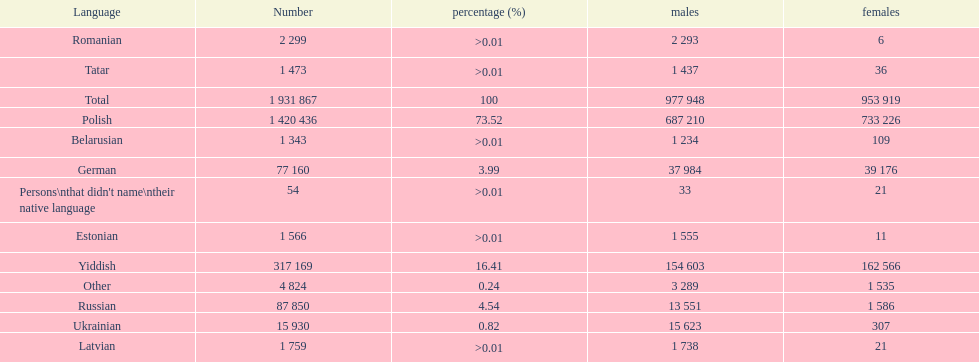Which language had the smallest number of females speaking it. Romanian. Could you parse the entire table as a dict? {'header': ['Language', 'Number', 'percentage (%)', 'males', 'females'], 'rows': [['Romanian', '2 299', '>0.01', '2 293', '6'], ['Tatar', '1 473', '>0.01', '1 437', '36'], ['Total', '1 931 867', '100', '977 948', '953 919'], ['Polish', '1 420 436', '73.52', '687 210', '733 226'], ['Belarusian', '1 343', '>0.01', '1 234', '109'], ['German', '77 160', '3.99', '37 984', '39 176'], ["Persons\\nthat didn't name\\ntheir native language", '54', '>0.01', '33', '21'], ['Estonian', '1 566', '>0.01', '1 555', '11'], ['Yiddish', '317 169', '16.41', '154 603', '162 566'], ['Other', '4 824', '0.24', '3 289', '1 535'], ['Russian', '87 850', '4.54', '13 551', '1 586'], ['Ukrainian', '15 930', '0.82', '15 623', '307'], ['Latvian', '1 759', '>0.01', '1 738', '21']]} 